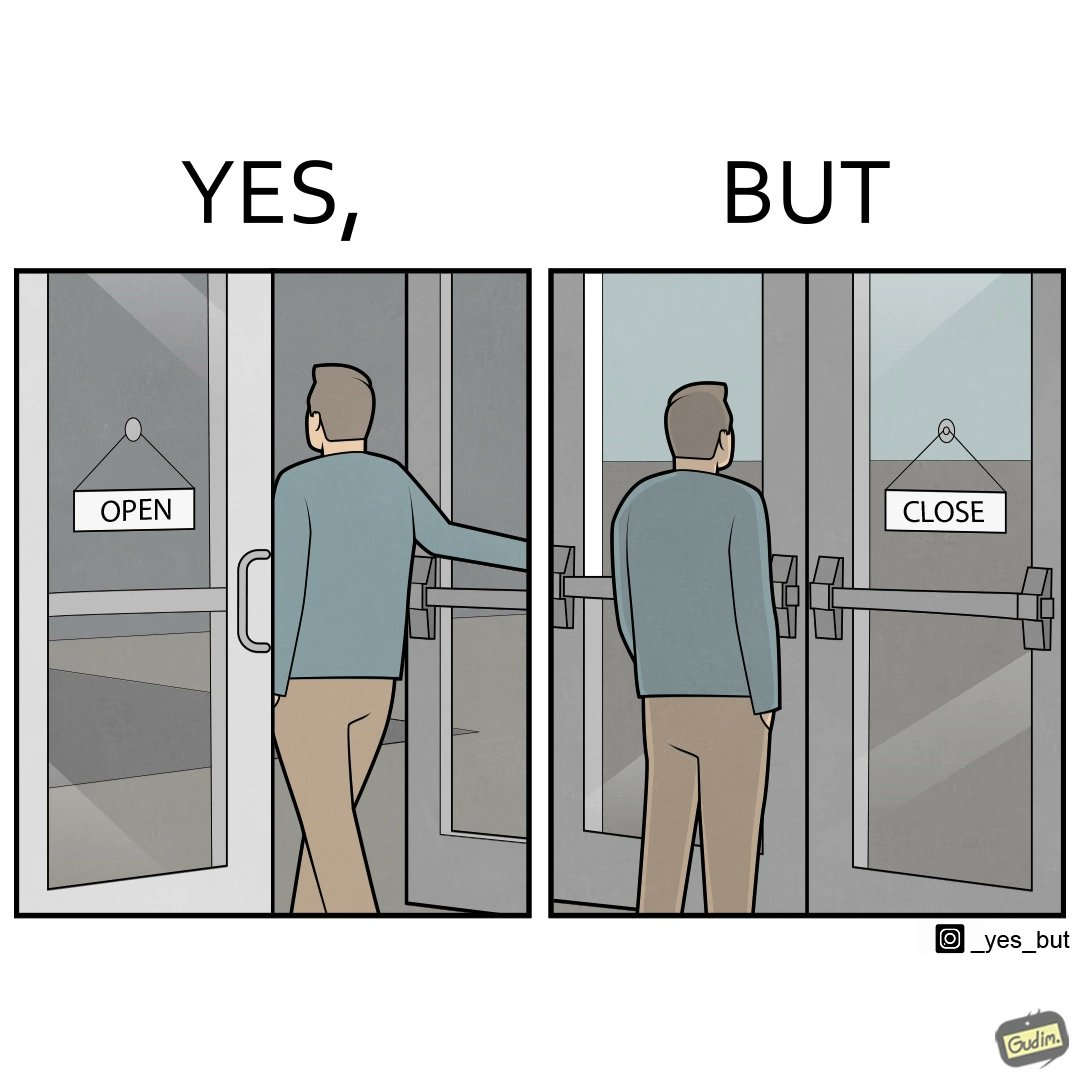What do you see in each half of this image? In the left part of the image: a person opening a door with the sign 'OPEN' In the right part of the image: a person standing near a door with the sign 'CLOSE' 